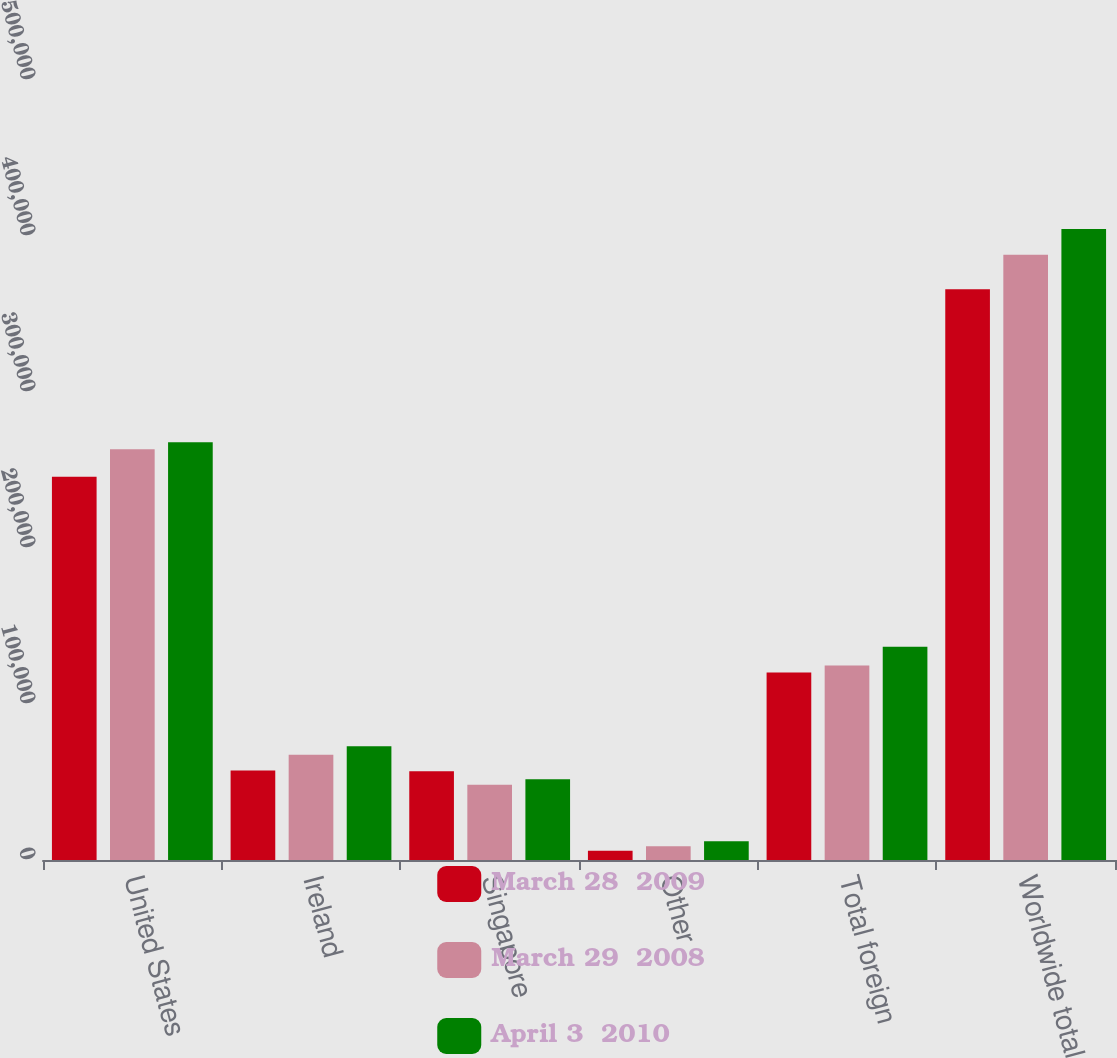<chart> <loc_0><loc_0><loc_500><loc_500><stacked_bar_chart><ecel><fcel>United States<fcel>Ireland<fcel>Singapore<fcel>Other<fcel>Total foreign<fcel>Worldwide total<nl><fcel>March 28  2009<fcel>245698<fcel>57369<fcel>56869<fcel>5942<fcel>120180<fcel>365878<nl><fcel>March 29  2008<fcel>263242<fcel>67497<fcel>48289<fcel>8879<fcel>124665<fcel>387907<nl><fcel>April 3  2010<fcel>267714<fcel>72947<fcel>51756<fcel>12013<fcel>136716<fcel>404430<nl></chart> 